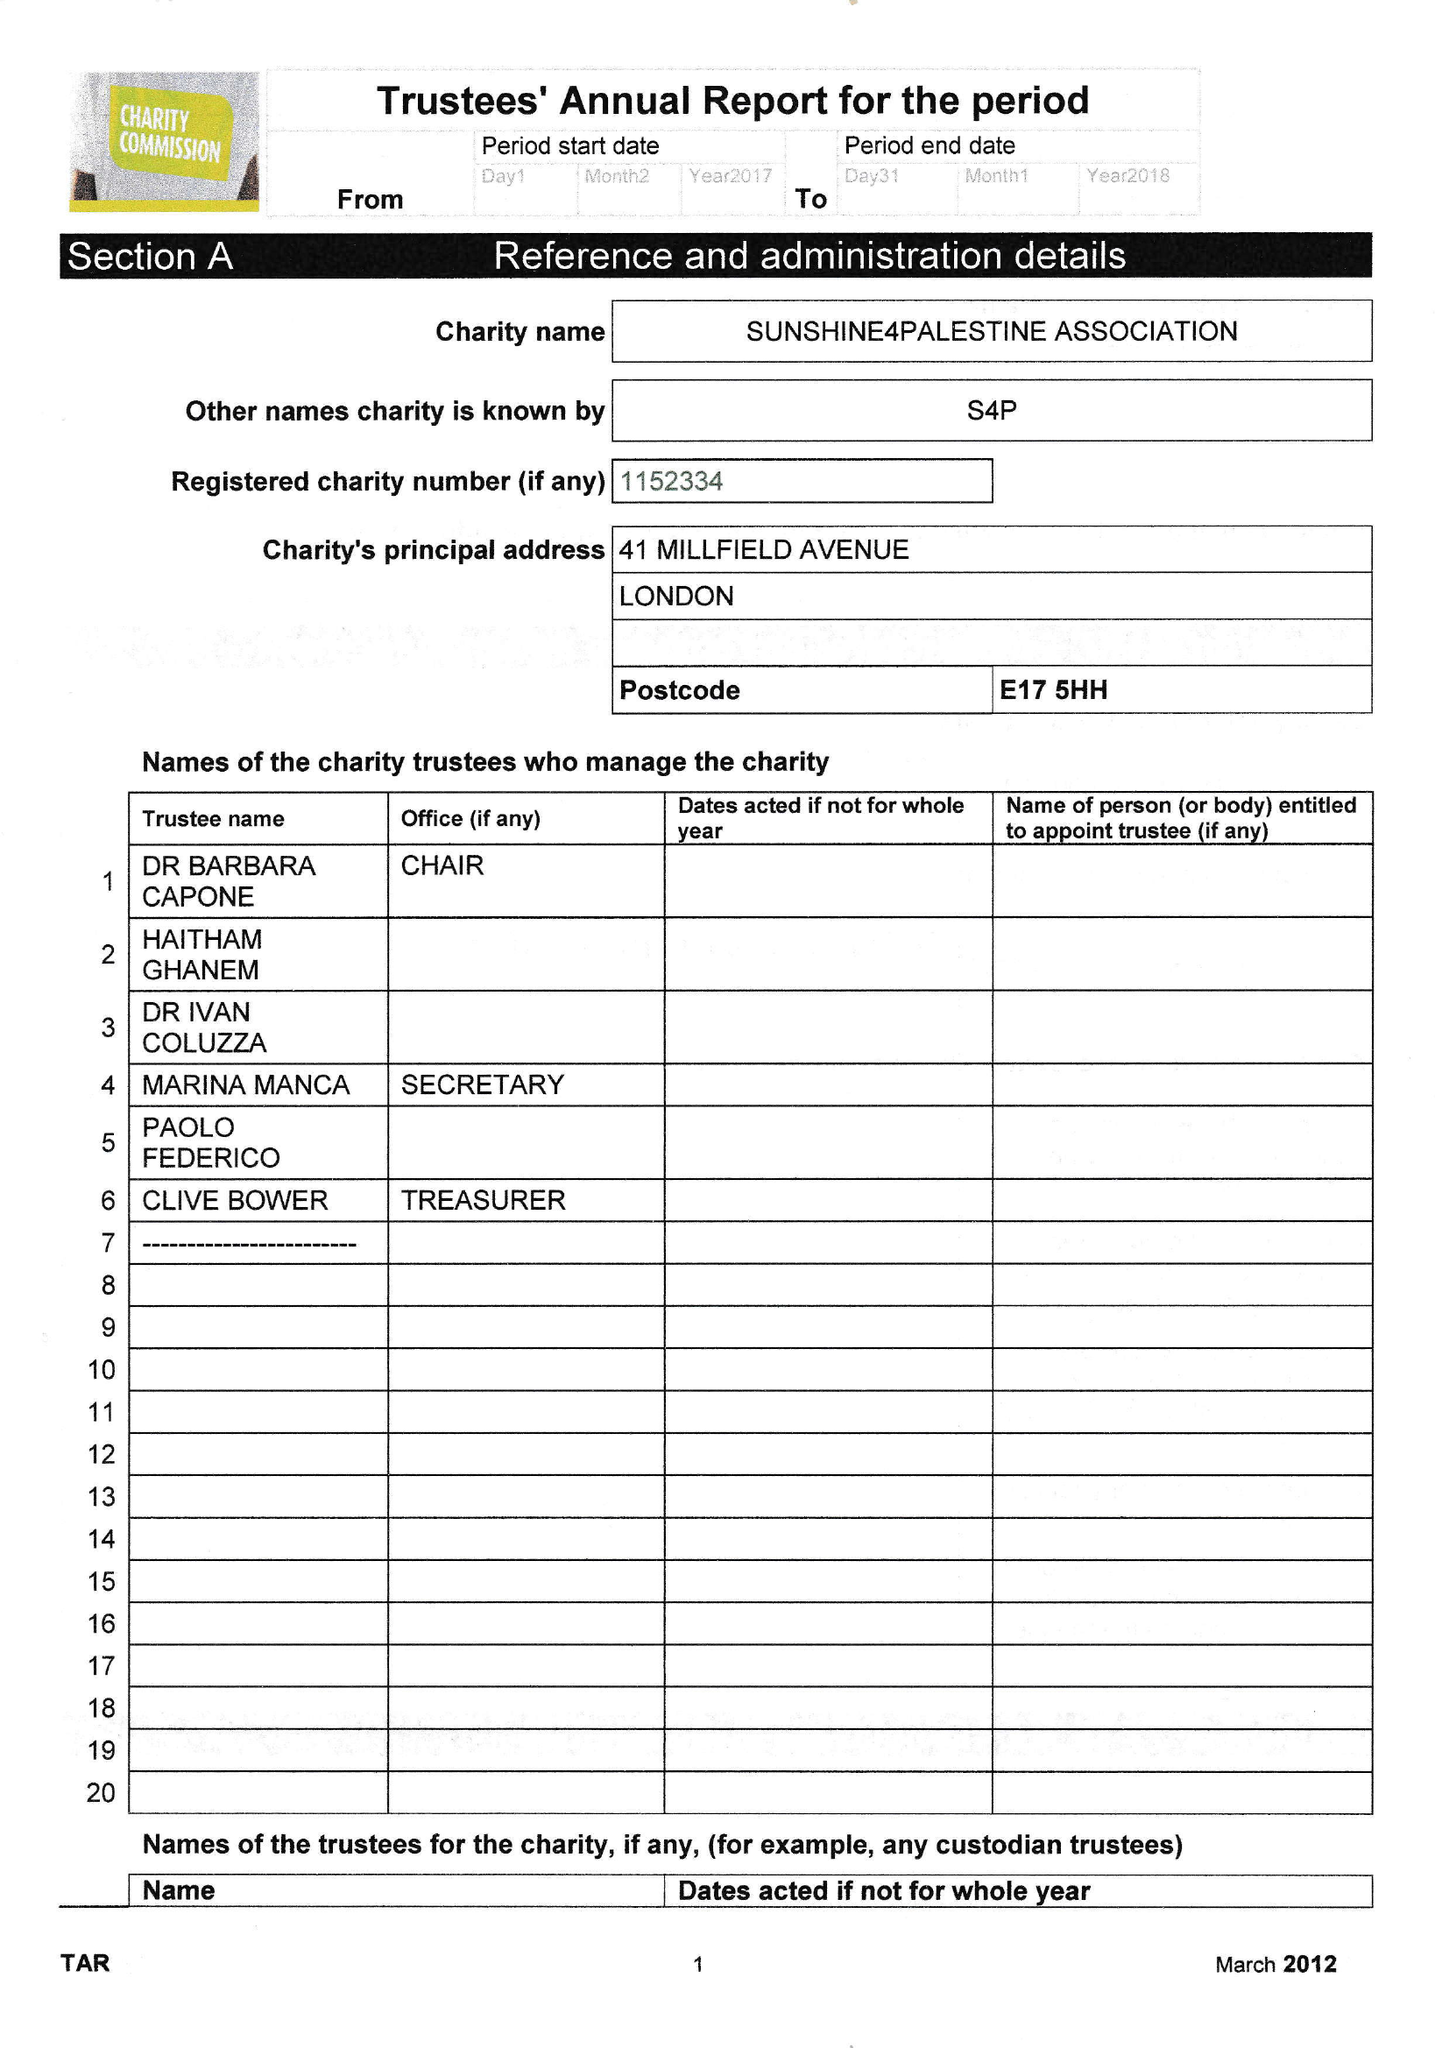What is the value for the address__post_town?
Answer the question using a single word or phrase. LONDON 